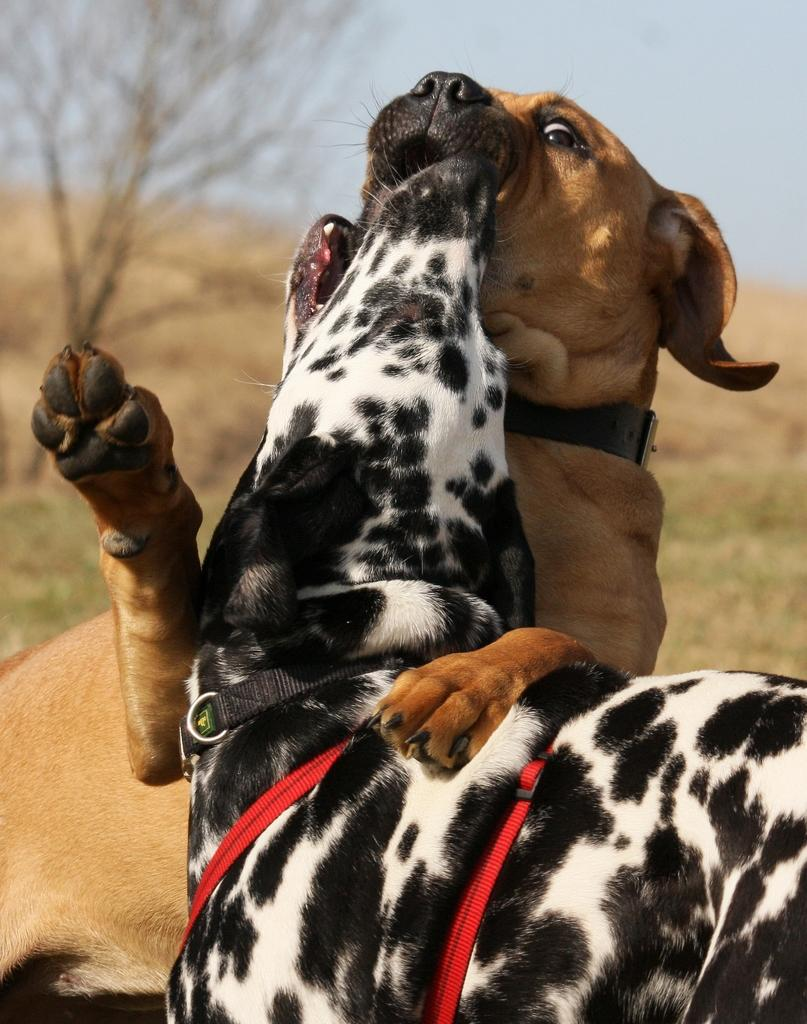What type of animals are in the image? There are dogs in the image. What can be seen in the background of the image? There is a tree and grass in the background of the image. What type of cap is the dog wearing in the image? There is no cap present in the image; the dogs are not wearing any clothing or accessories. 